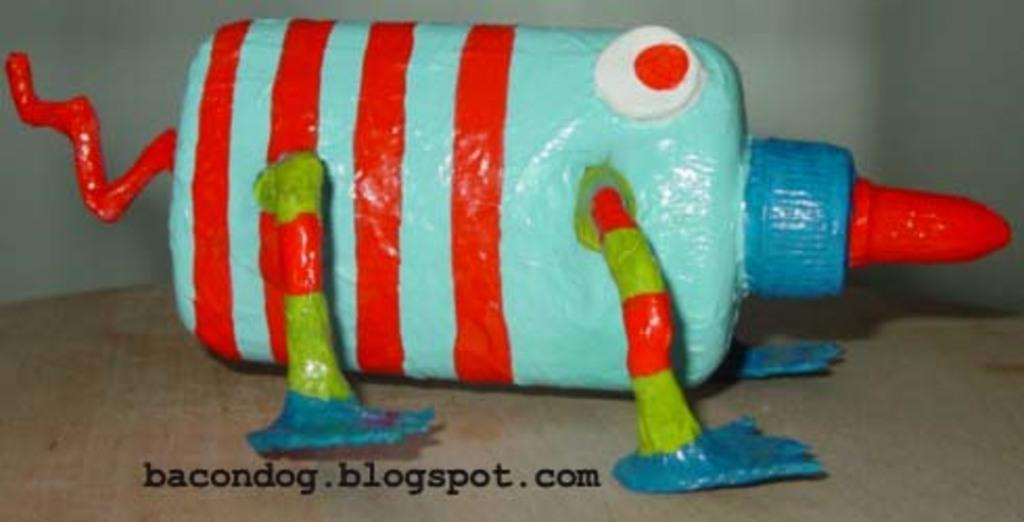What object can be seen in the image? There is a toy in the image. Where is the toy located? The toy is on a table. What can be seen in the background of the image? There is a wall in the background of the image. Is there any text visible in the image? Yes, there is text written on the wall. Can you see any crackers floating in the stream in the image? There is no stream or crackers present in the image. 